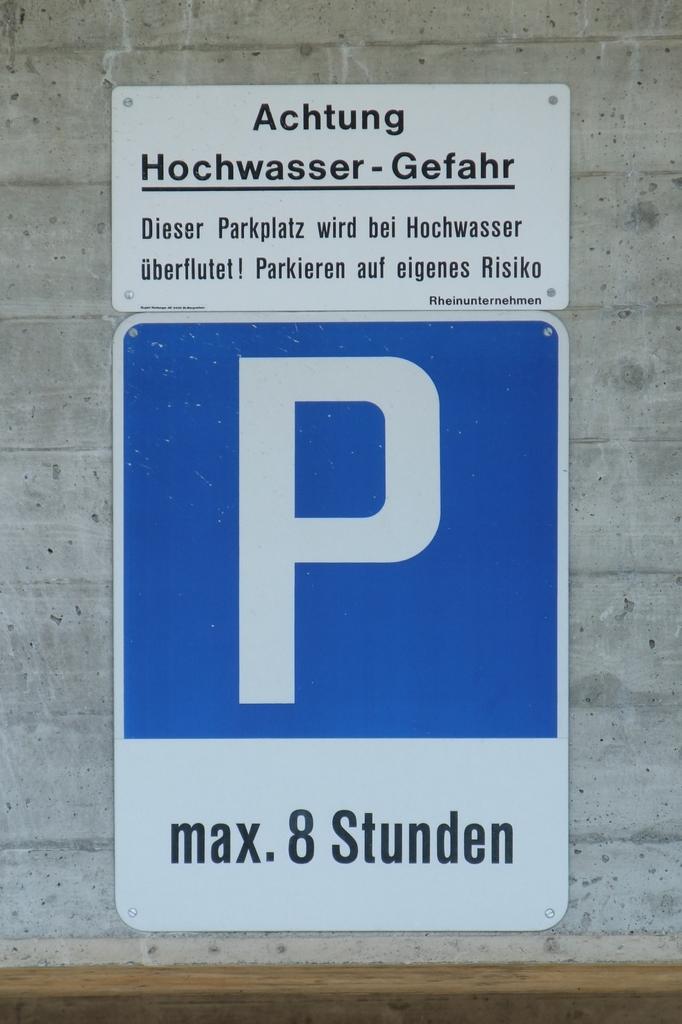What is the big letter shown on blue background?
Offer a very short reply. P. 